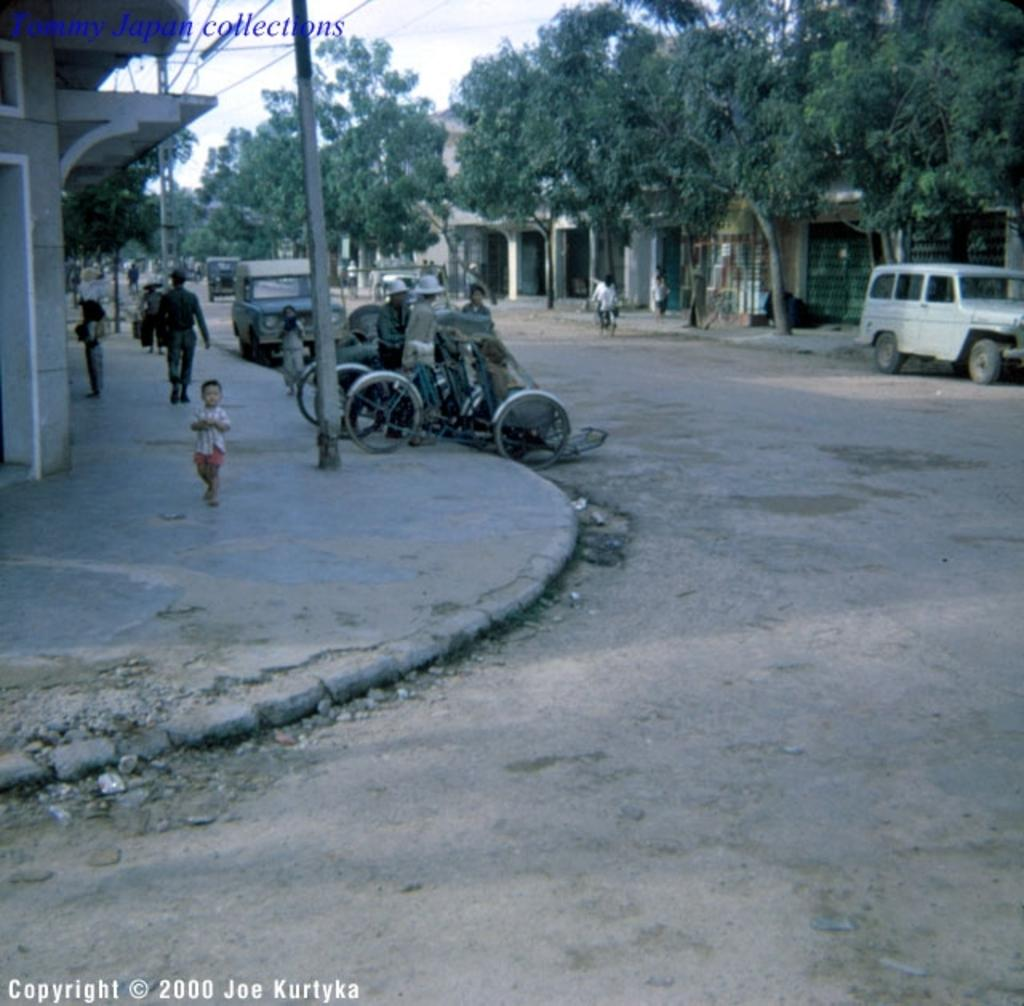Who or what can be seen in the image? There are people in the image. What else is present in the image besides people? There are vehicles, poles, a road, buildings, and text written at the top and bottom of the image. Can you describe the setting of the image? The image features a road, buildings, and poles, suggesting an urban or suburban environment. The sky is visible in the background. What might the text at the top and bottom of the image indicate? The text could be a title, caption, or other information related to the image. What type of plantation can be seen in the image? There is no plantation present in the image. How many ducks are visible in the image? There are no ducks present in the image. 